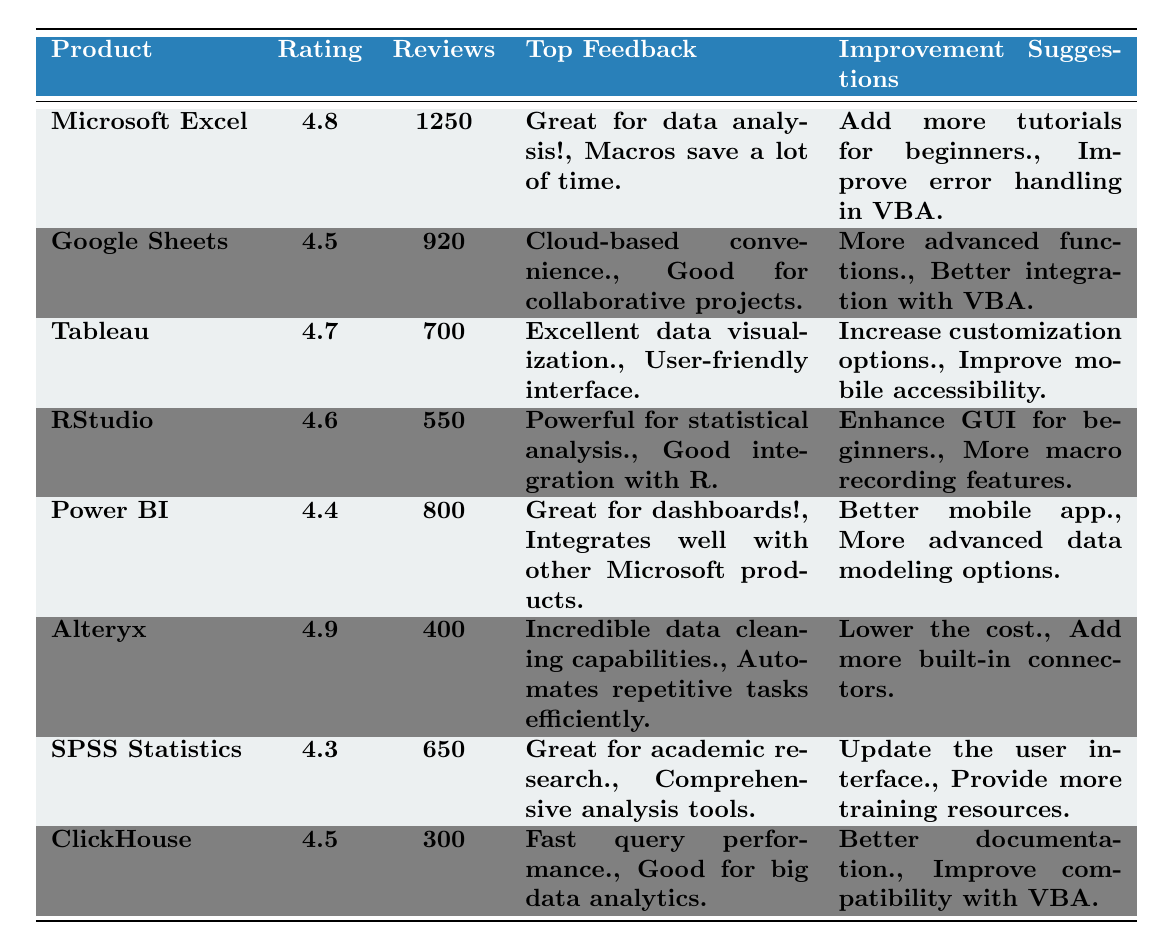What product has the highest rating? The table shows that Alteryx has the highest rating of 4.9.
Answer: Alteryx How many reviews did Microsoft Excel receive? According to the table, Microsoft Excel received 1250 reviews.
Answer: 1250 What is the rating difference between RStudio and Power BI? RStudio has a rating of 4.6 while Power BI has a rating of 4.4. The difference is 4.6 - 4.4 = 0.2.
Answer: 0.2 Which product has the least number of reviews? The product with the least number of reviews is ClickHouse, with 300 reviews.
Answer: ClickHouse Is the top feedback for Tableau focused on data visualization? Yes, the top feedback for Tableau includes "Excellent data visualization," confirming its focus on that aspect.
Answer: Yes How many total reviews were received across all products? The total reviews can be calculated by summing individual reviews: 1250 + 920 + 700 + 550 + 800 + 400 + 650 + 300 = 5,570.
Answer: 5570 Which two products have a 4.5 rating? Both Google Sheets and ClickHouse have a rating of 4.5 according to the table.
Answer: Google Sheets and ClickHouse What improvement suggestion is common for both Microsoft Excel and Google Sheets? Both products suggest improvements related to VBA — Microsoft Excel mentions "Improve error handling in VBA" and Google Sheets suggests "Better integration with VBA."
Answer: Yes What percentage of reviews does Alteryx represent among the total reviews? Alteryx received 400 reviews. First, find the total reviews which is 5,570. So, (400/5570) * 100 ≈ 7.17%.
Answer: 7.17% Which product has the most significant focus on data analysis tools in its feedback? SPSS Statistics is noted for "Comprehensive analysis tools", indicating a strong focus on data analysis.
Answer: SPSS Statistics 